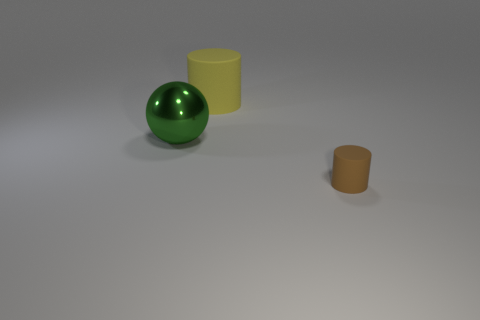Add 2 blue rubber cylinders. How many objects exist? 5 Subtract all balls. How many objects are left? 2 Subtract all blue metal objects. Subtract all small cylinders. How many objects are left? 2 Add 2 small rubber cylinders. How many small rubber cylinders are left? 3 Add 3 small cyan metal things. How many small cyan metal things exist? 3 Subtract 0 purple spheres. How many objects are left? 3 